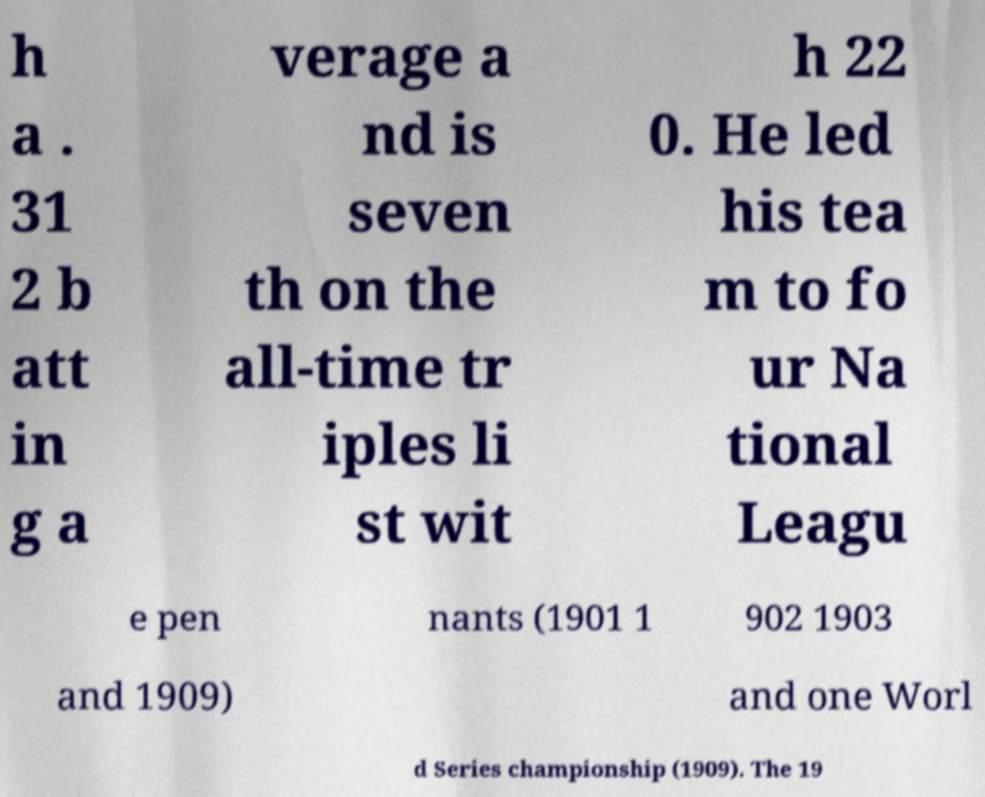There's text embedded in this image that I need extracted. Can you transcribe it verbatim? h a . 31 2 b att in g a verage a nd is seven th on the all-time tr iples li st wit h 22 0. He led his tea m to fo ur Na tional Leagu e pen nants (1901 1 902 1903 and 1909) and one Worl d Series championship (1909). The 19 